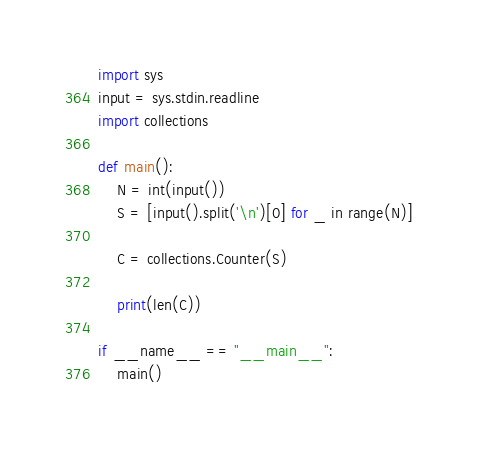Convert code to text. <code><loc_0><loc_0><loc_500><loc_500><_Cython_>import sys
input = sys.stdin.readline
import collections

def main():
    N = int(input())
    S = [input().split('\n')[0] for _ in range(N)]

    C = collections.Counter(S)

    print(len(C))

if __name__ == "__main__":
    main()</code> 